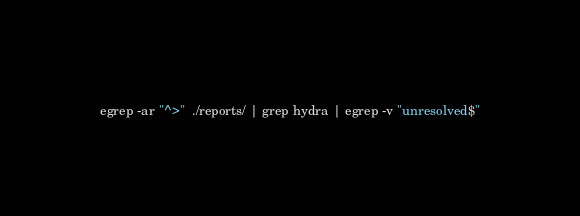<code> <loc_0><loc_0><loc_500><loc_500><_Bash_>egrep -ar "^>"  ./reports/ | grep hydra | egrep -v "unresolved$"</code> 